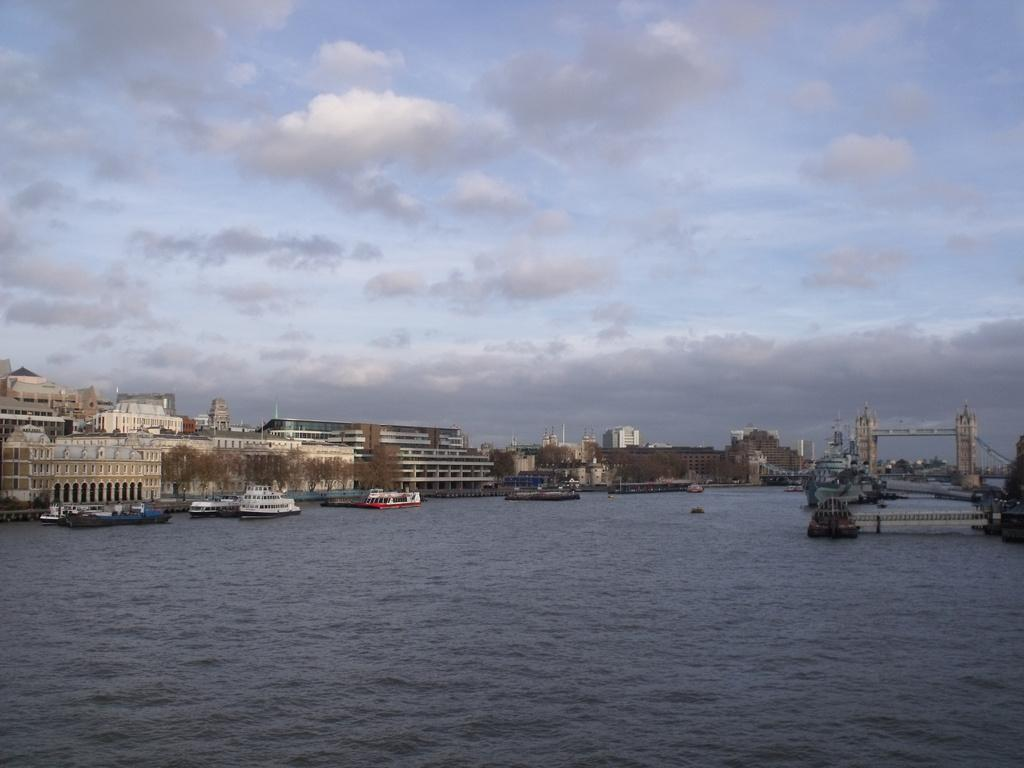What type of structures can be seen in the image? There are many buildings in the image. What other natural elements are present in the image? There are trees in the image. What can be seen in the water in the image? There are boats in the water in the image. Is there any infrastructure connecting different areas in the image? Yes, there is a bridge in the image. How would you describe the weather based on the image? The sky is cloudy in the image. Where is the faucet located in the image? There is no faucet present in the image. What type of soda is being served in the boats in the image? There is no soda or indication of any beverages in the image; it features boats in the water. 